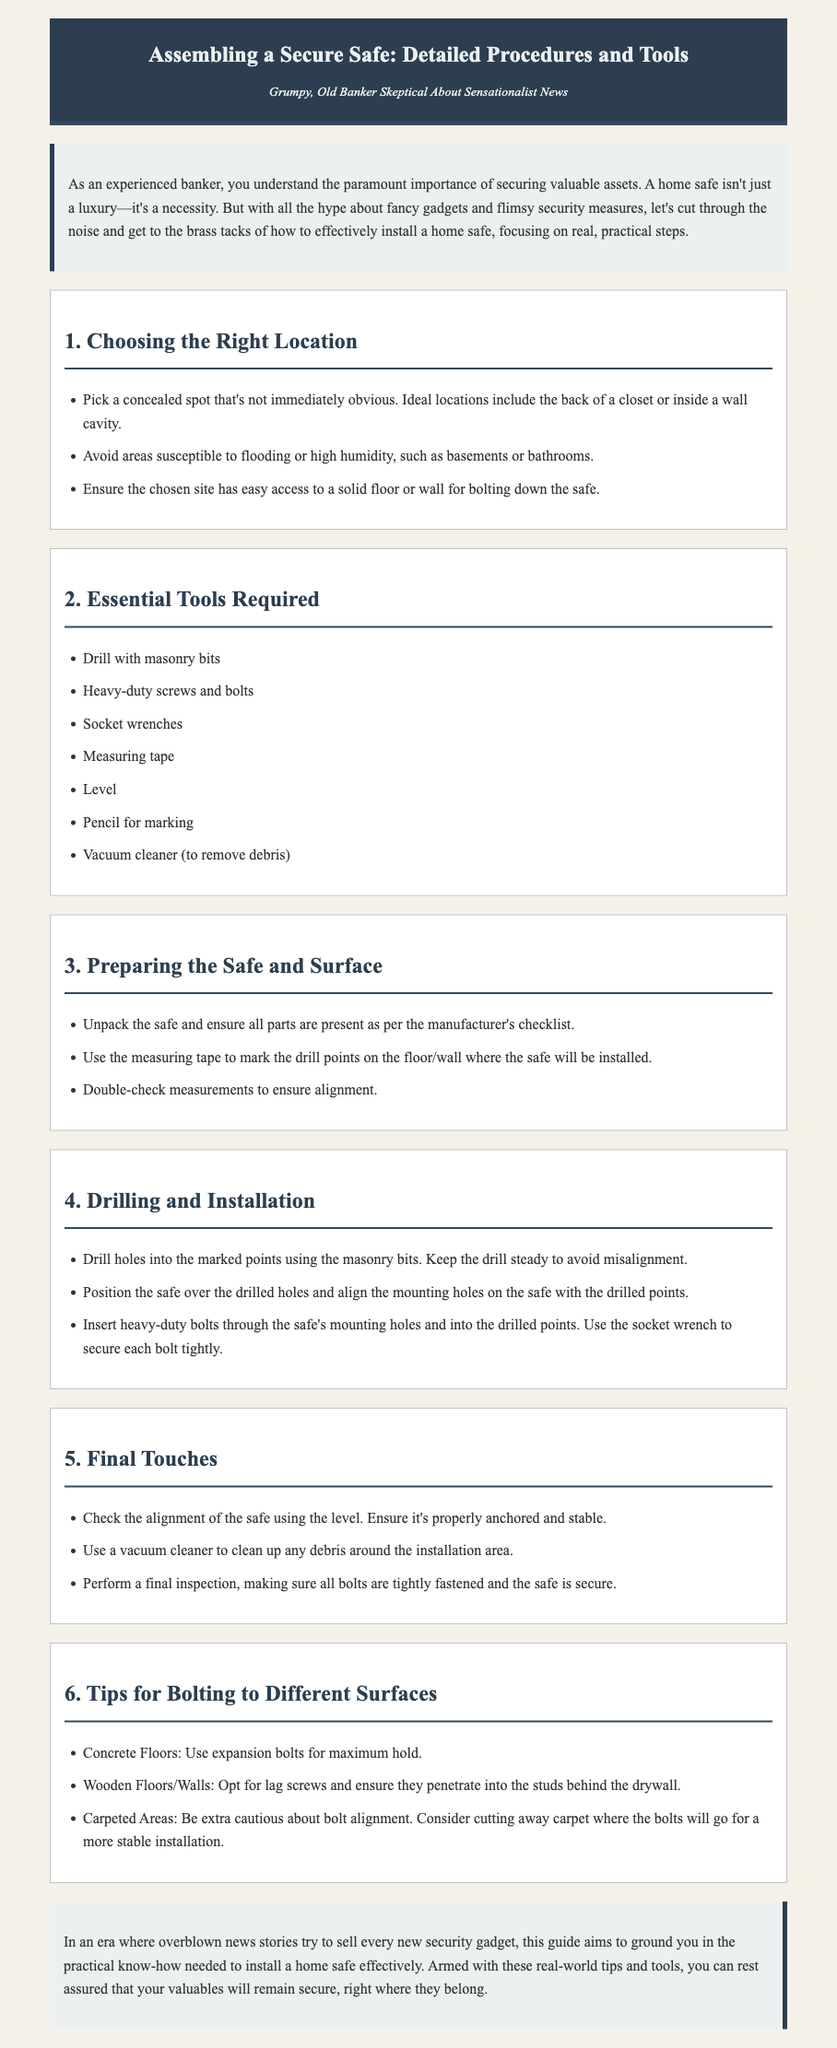What is the first step in assembling the safe? The first step is choosing the right location for the safe installation.
Answer: Choosing the Right Location What tool is required for drilling into masonry? The document specifically mentions using drill with masonry bits for this purpose.
Answer: Drill with masonry bits How should the safe be anchored to concrete floors? The proper method for anchoring to concrete floors is to use expansion bolts for maximum hold.
Answer: Expansion bolts What is the purpose of using a level after installation? The level is used to check the alignment of the safe and ensure that it's properly anchored and stable.
Answer: Check alignment What should be removed after the installation? The document advises using a vacuum cleaner to remove debris around the installation area.
Answer: Debris What common issue should be considered when installing on carpeted areas? One should be cautious about bolt alignment and consider cutting away carpet where the bolts will go.
Answer: Bolt alignment 